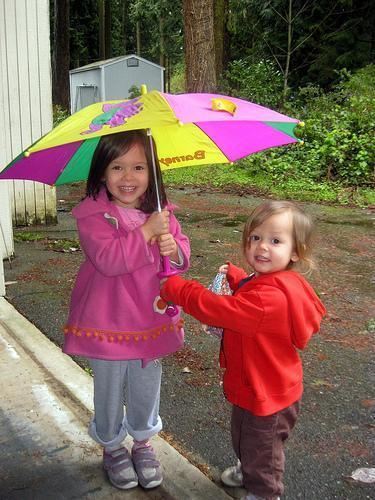How many hands are on the umbrella?
Give a very brief answer. 3. 